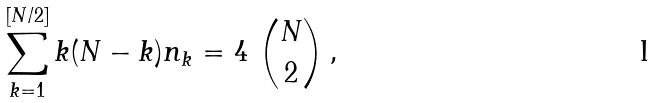Convert formula to latex. <formula><loc_0><loc_0><loc_500><loc_500>\sum _ { k = 1 } ^ { [ N / 2 ] } k ( N - k ) n _ { k } = 4 \ { N \choose 2 } \, ,</formula> 